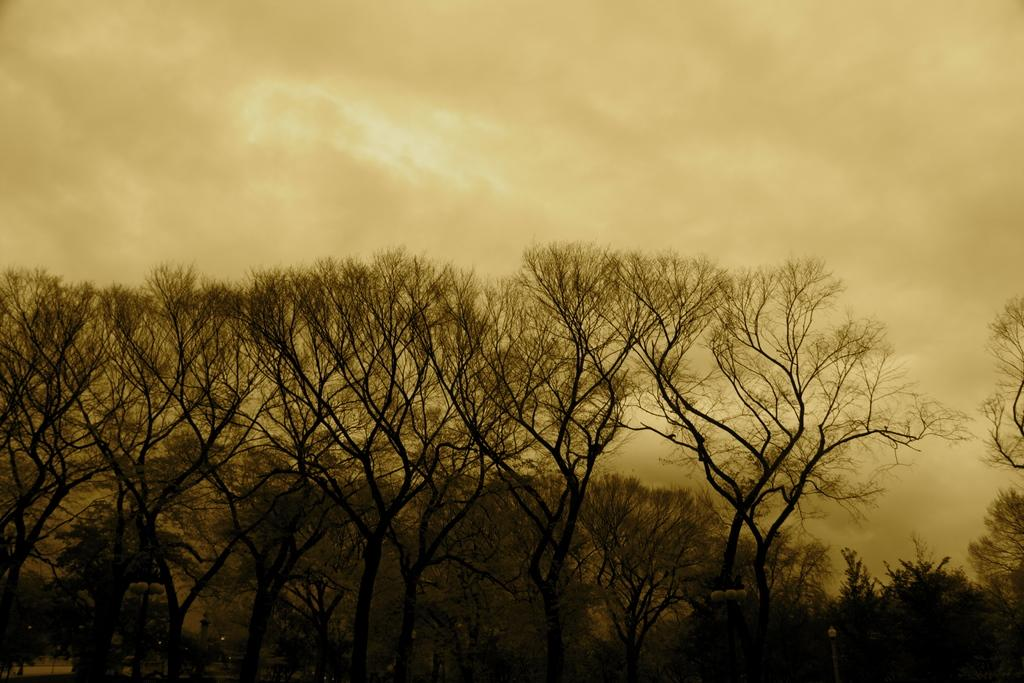What types of vegetation are present on the ground in the image? There are trees and plants on the ground in the image. Can you describe the sky in the background of the image? The sky in the background of the image has clouds. What type of glove is the aunt wearing in the image? There is no glove or aunt present in the image; it only features trees, plants, and clouds. 